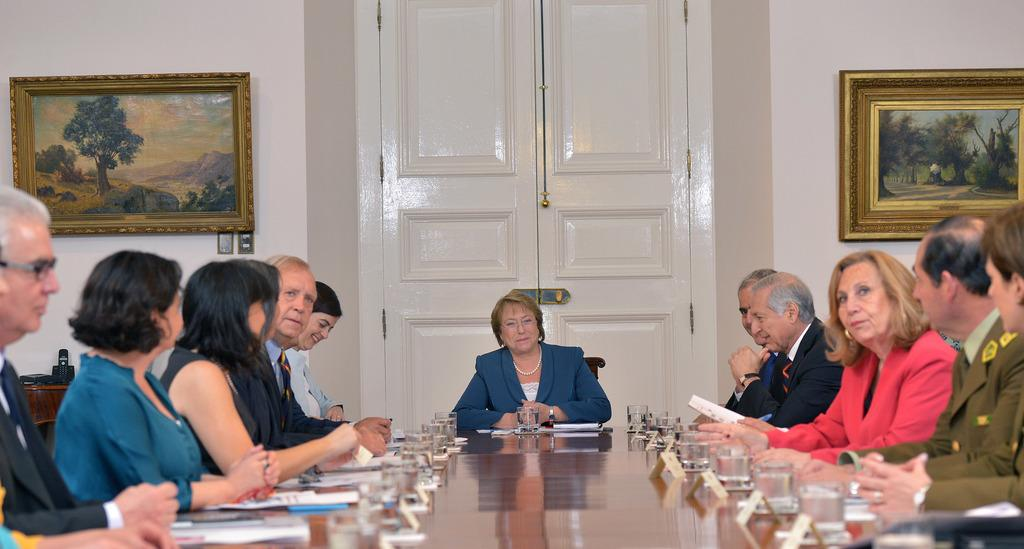What is happening in the image? There is a group of people sitting around a table. Can you describe the woman in the middle of the group? The woman in the middle of the group is wearing a blue suit. What can be seen behind the woman? There is a white door behind the woman. What type of haircut does the woman have in the image? There is no information about the woman's haircut in the image. 